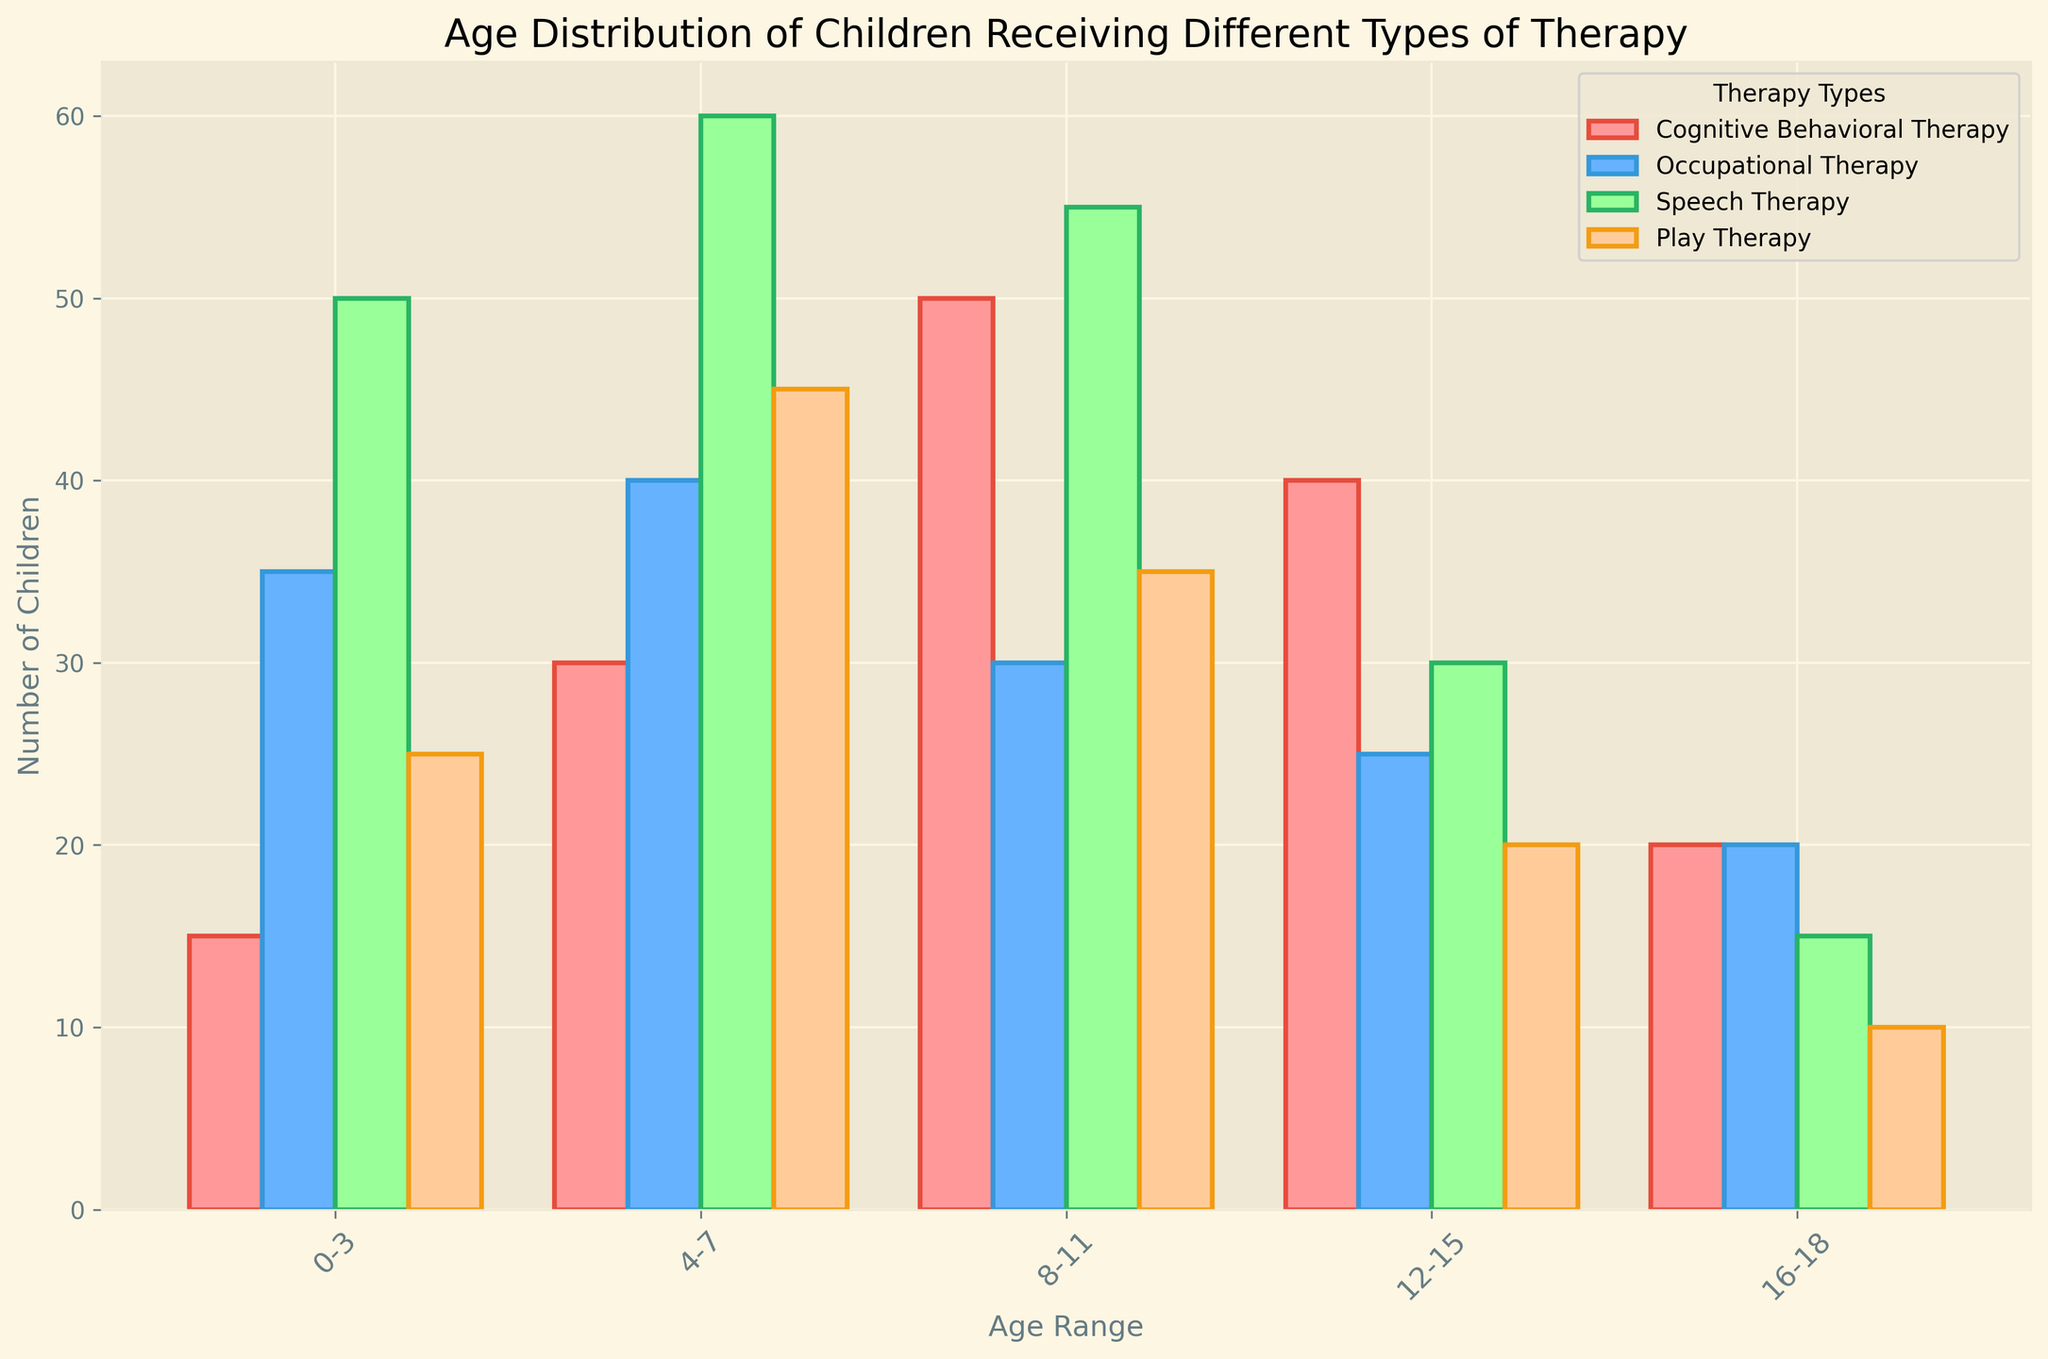What's the total number of children receiving Cognitive Behavioral Therapy across all age groups? Add the numbers for Cognitive Behavioral Therapy for each age group: 15 (0-3) + 30 (4-7) + 50 (8-11) + 40 (12-15) + 20 (16-18) = 155
Answer: 155 Which age group has the highest number of children receiving Play Therapy? Compare the values for Play Therapy across all age groups: 25 (0-3), 45 (4-7), 35 (8-11), 20 (12-15), 10 (16-18). The highest number is 45, which corresponds to age range 4-7
Answer: 4-7 Is the number of children receiving Occupational Therapy in the 12-15 age group greater than, equal to, or less than the number receiving it in the 8-11 age group? Compare the values: 25 for the 12-15 age group and 30 for the 8-11 age group. 25 is less than 30
Answer: Less than What's the average number of children receiving Speech Therapy across all age groups? Add the numbers for Speech Therapy: 50 (0-3) + 60 (4-7) + 55 (8-11) + 30 (12-15) + 15 (16-18) = 210. Divide by the number of age groups: 210 / 5 = 42
Answer: 42 Which therapy type has the least number of children in the 16-18 age group? Compare the values for the 16-18 age group: 20 (Cognitive Behavioral Therapy), 20 (Occupational Therapy), 15 (Speech Therapy), 10 (Play Therapy). The lowest number is 10 for Play Therapy
Answer: Play Therapy How many more children are receiving Speech Therapy than Cognitive Behavioral Therapy in the 8-11 age group? Subtract the number receiving Cognitive Behavioral Therapy from those receiving Speech Therapy in the 8-11 age group: 55 - 50 = 5
Answer: 5 What is the combined number of children receiving Play Therapy and Occupational Therapy in the 4-7 age group? Add the numbers for Play Therapy and Occupational Therapy in the 4-7 age group: 45 + 40 = 85
Answer: 85 In which age group is the number of children receiving Cognitive Behavioral Therapy closest to the number receiving Occupational Therapy? Compare the differences for each age group: 20 - 20 = 0 (16-18), 40 - 25 = 15 (12-15), 50 - 30 = 20 (8-11), 30 - 40 = -10 (4-7), 15 - 35 = -20 (0-3). The smallest difference in absolute value is 0 for the 16-18 age group
Answer: 16-18 What is the ratio of children receiving Play Therapy to those receiving Cognitive Behavioral Therapy in the 0-3 age group? Divide the number of children receiving Play Therapy by those receiving Cognitive Behavioral Therapy in the 0-3 age group: 25 / 15 = 1.67
Answer: 1.67 